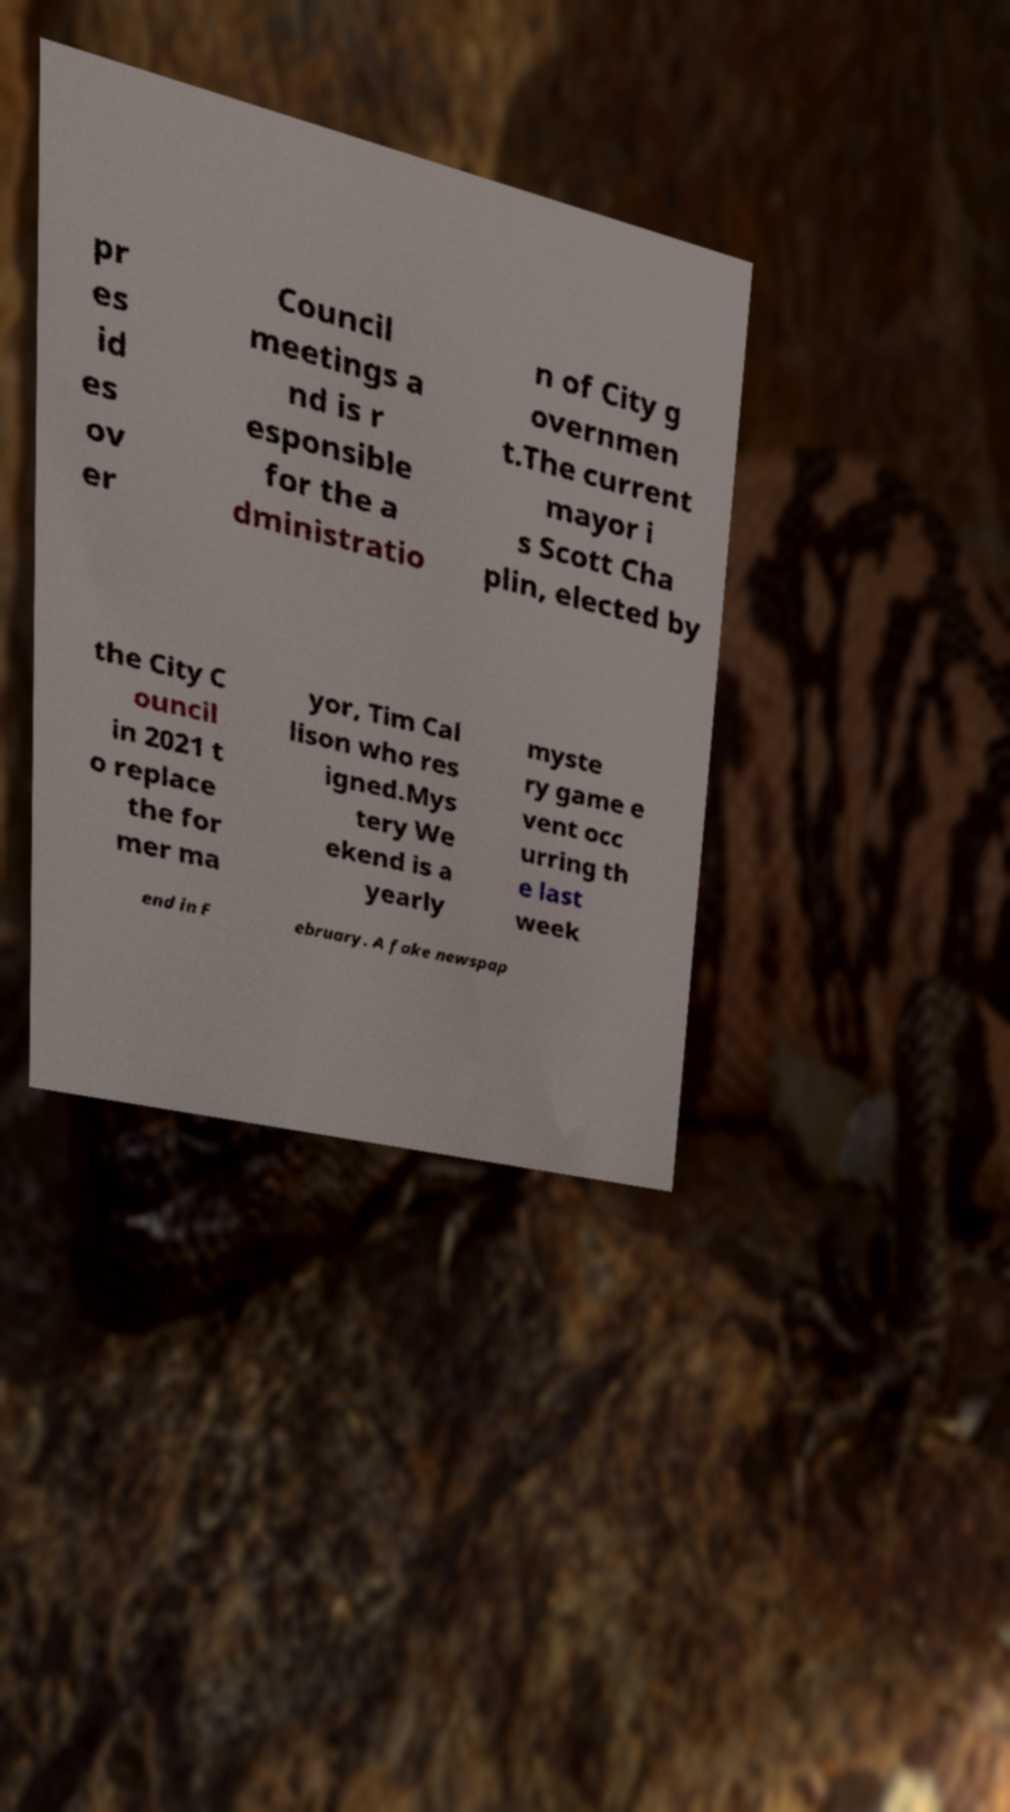Please read and relay the text visible in this image. What does it say? pr es id es ov er Council meetings a nd is r esponsible for the a dministratio n of City g overnmen t.The current mayor i s Scott Cha plin, elected by the City C ouncil in 2021 t o replace the for mer ma yor, Tim Cal lison who res igned.Mys tery We ekend is a yearly myste ry game e vent occ urring th e last week end in F ebruary. A fake newspap 